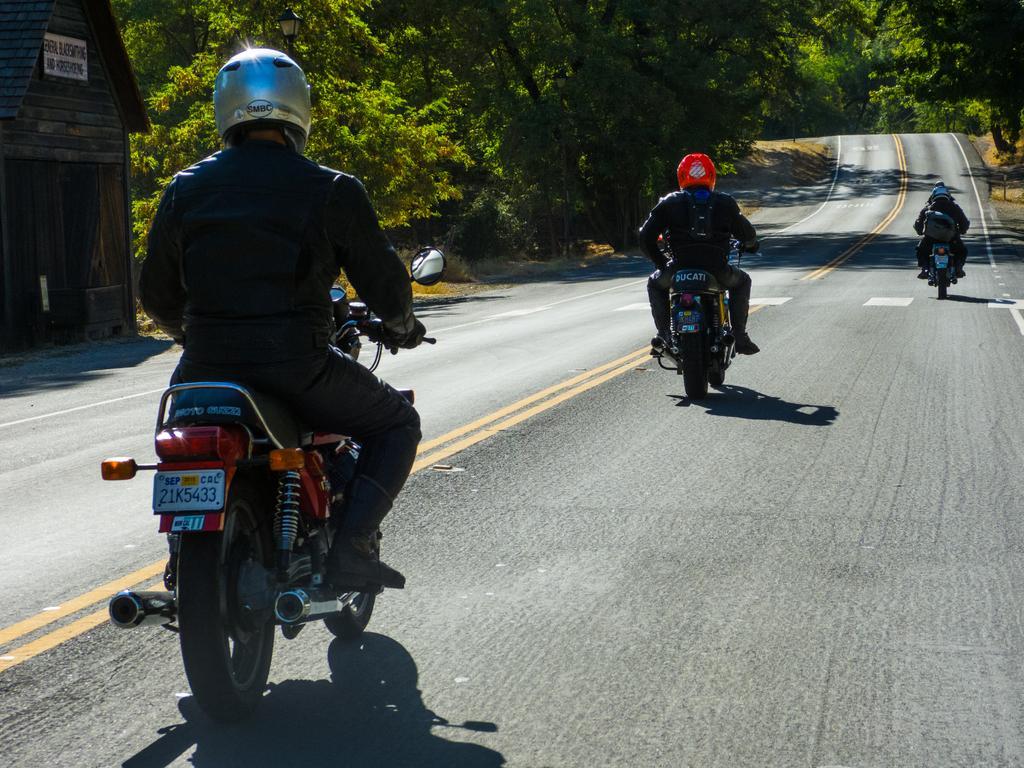Please provide a concise description of this image. In this picture there are three persons riding motorbike on the road. On the left side of the image there is a board on the house and there is text on the board. At the back there are trees. At the bottom there is a road and there is grass. 